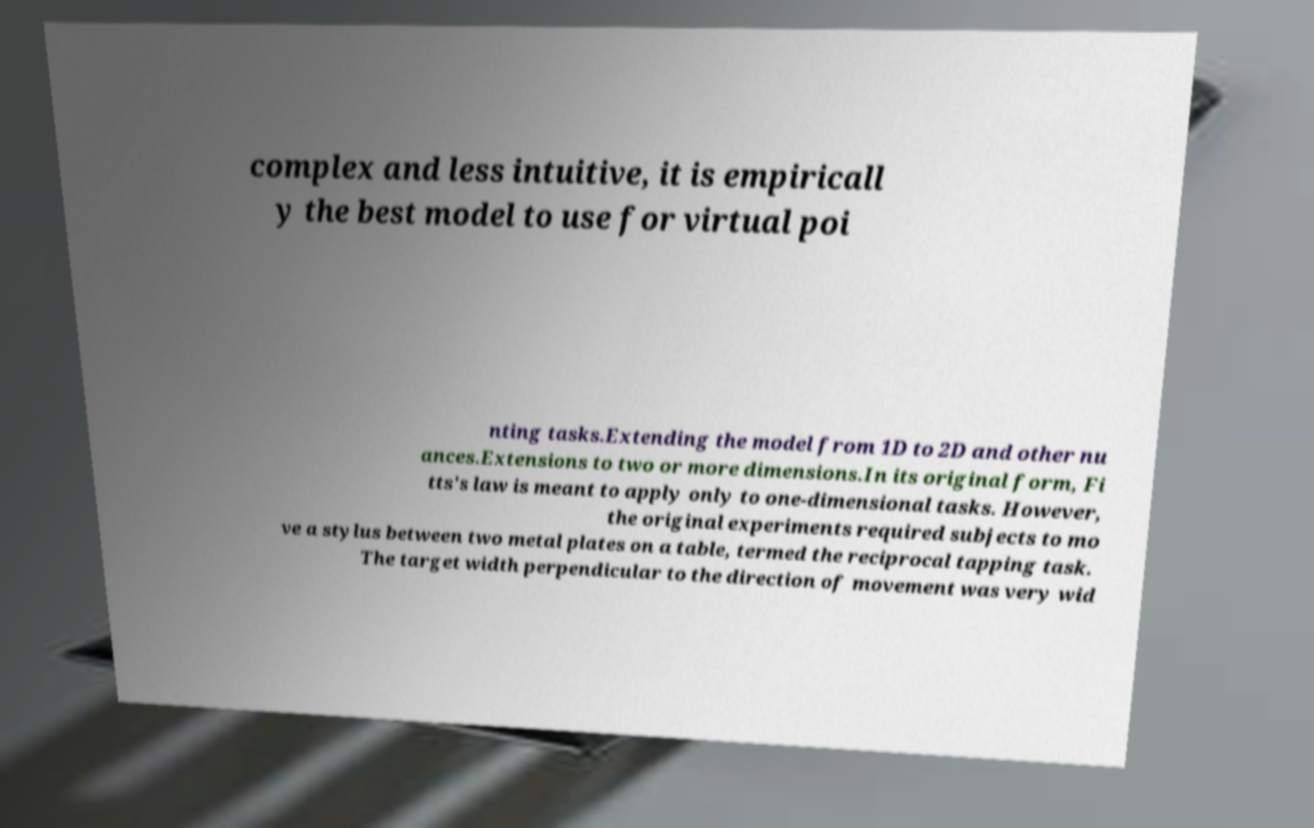Can you read and provide the text displayed in the image?This photo seems to have some interesting text. Can you extract and type it out for me? complex and less intuitive, it is empiricall y the best model to use for virtual poi nting tasks.Extending the model from 1D to 2D and other nu ances.Extensions to two or more dimensions.In its original form, Fi tts's law is meant to apply only to one-dimensional tasks. However, the original experiments required subjects to mo ve a stylus between two metal plates on a table, termed the reciprocal tapping task. The target width perpendicular to the direction of movement was very wid 